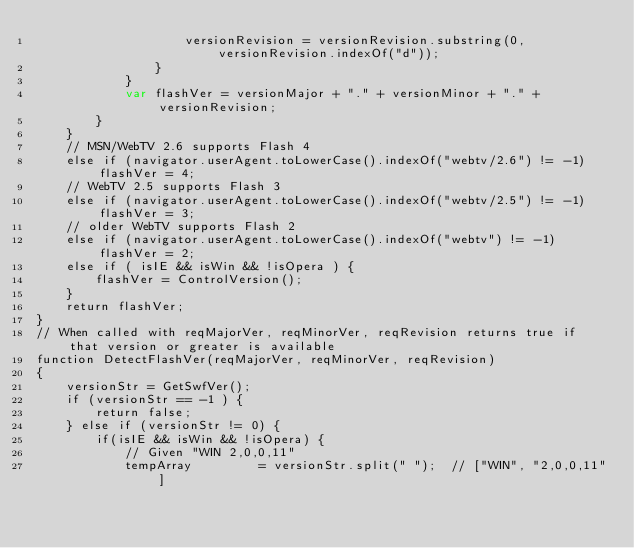Convert code to text. <code><loc_0><loc_0><loc_500><loc_500><_HTML_>					versionRevision = versionRevision.substring(0, versionRevision.indexOf("d"));
				}
			}
			var flashVer = versionMajor + "." + versionMinor + "." + versionRevision;
		}
	}
	// MSN/WebTV 2.6 supports Flash 4
	else if (navigator.userAgent.toLowerCase().indexOf("webtv/2.6") != -1) flashVer = 4;
	// WebTV 2.5 supports Flash 3
	else if (navigator.userAgent.toLowerCase().indexOf("webtv/2.5") != -1) flashVer = 3;
	// older WebTV supports Flash 2
	else if (navigator.userAgent.toLowerCase().indexOf("webtv") != -1) flashVer = 2;
	else if ( isIE && isWin && !isOpera ) {
		flashVer = ControlVersion();
	}	
	return flashVer;
}
// When called with reqMajorVer, reqMinorVer, reqRevision returns true if that version or greater is available
function DetectFlashVer(reqMajorVer, reqMinorVer, reqRevision)
{
	versionStr = GetSwfVer();
	if (versionStr == -1 ) {
		return false;
	} else if (versionStr != 0) {
		if(isIE && isWin && !isOpera) {
			// Given "WIN 2,0,0,11"
			tempArray         = versionStr.split(" "); 	// ["WIN", "2,0,0,11"]</code> 